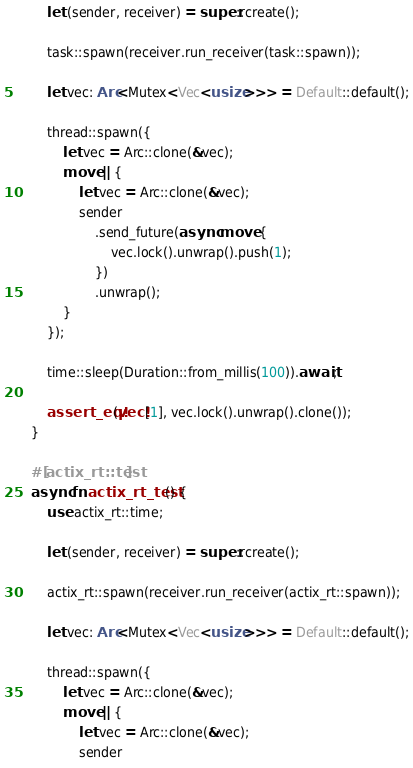Convert code to text. <code><loc_0><loc_0><loc_500><loc_500><_Rust_>
        let (sender, receiver) = super::create();

        task::spawn(receiver.run_receiver(task::spawn));

        let vec: Arc<Mutex<Vec<usize>>> = Default::default();

        thread::spawn({
            let vec = Arc::clone(&vec);
            move || {
                let vec = Arc::clone(&vec);
                sender
                    .send_future(async move {
                        vec.lock().unwrap().push(1);
                    })
                    .unwrap();
            }
        });

        time::sleep(Duration::from_millis(100)).await;

        assert_eq!(vec![1], vec.lock().unwrap().clone());
    }

    #[actix_rt::test]
    async fn actix_rt_test() {
        use actix_rt::time;

        let (sender, receiver) = super::create();

        actix_rt::spawn(receiver.run_receiver(actix_rt::spawn));

        let vec: Arc<Mutex<Vec<usize>>> = Default::default();

        thread::spawn({
            let vec = Arc::clone(&vec);
            move || {
                let vec = Arc::clone(&vec);
                sender</code> 